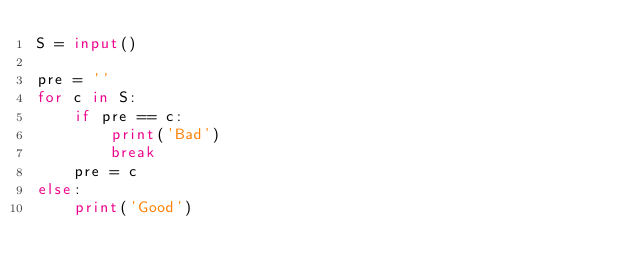<code> <loc_0><loc_0><loc_500><loc_500><_Python_>S = input()

pre = ''
for c in S:
    if pre == c:
        print('Bad')
        break
    pre = c
else:
    print('Good')</code> 